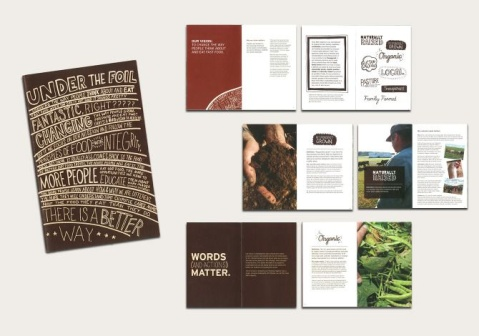Are there any elements in the prints that indicate their target audience? Yes, elements such as the sophisticated use of typography, organic motifs, and the direct addressing of the consumer suggest these materials target an audience interested in environmental issues, health, and ethical consumption. The quality and style of the print materials indicate they are designed to appeal to a conscientious demographic that values transparency and sustainability in their choices. 